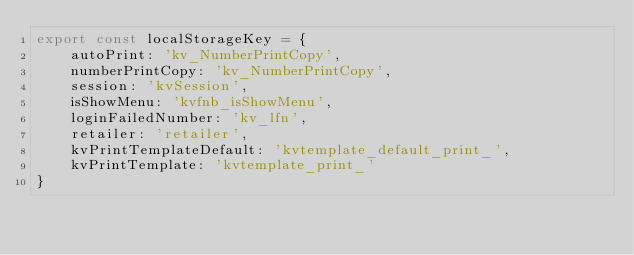Convert code to text. <code><loc_0><loc_0><loc_500><loc_500><_TypeScript_>export const localStorageKey = {
    autoPrint: 'kv_NumberPrintCopy',
    numberPrintCopy: 'kv_NumberPrintCopy',
    session: 'kvSession',
    isShowMenu: 'kvfnb_isShowMenu',
    loginFailedNumber: 'kv_lfn',
    retailer: 'retailer',
    kvPrintTemplateDefault: 'kvtemplate_default_print_',
    kvPrintTemplate: 'kvtemplate_print_'
}
</code> 